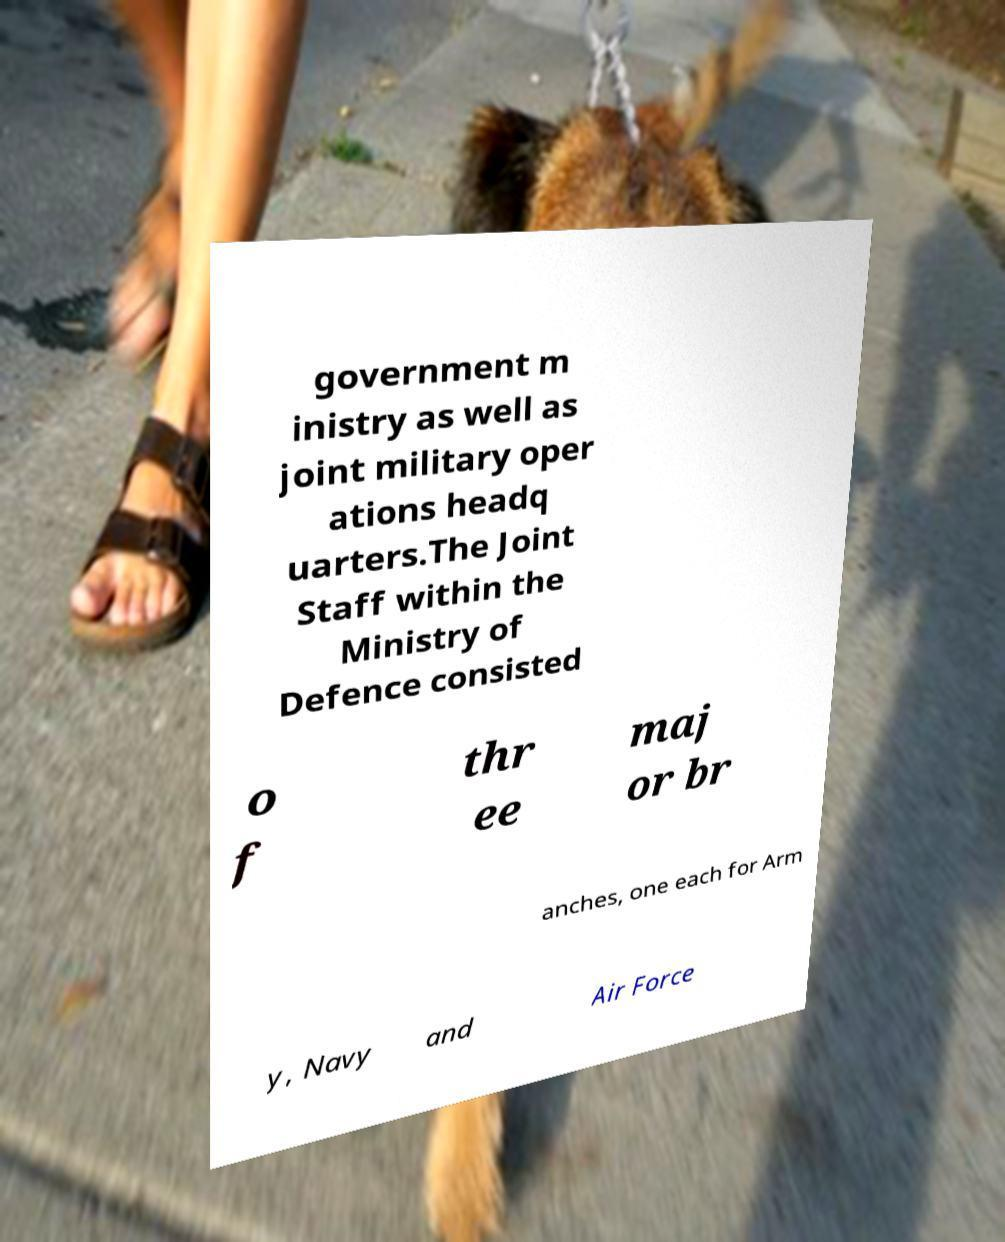Can you read and provide the text displayed in the image?This photo seems to have some interesting text. Can you extract and type it out for me? government m inistry as well as joint military oper ations headq uarters.The Joint Staff within the Ministry of Defence consisted o f thr ee maj or br anches, one each for Arm y, Navy and Air Force 